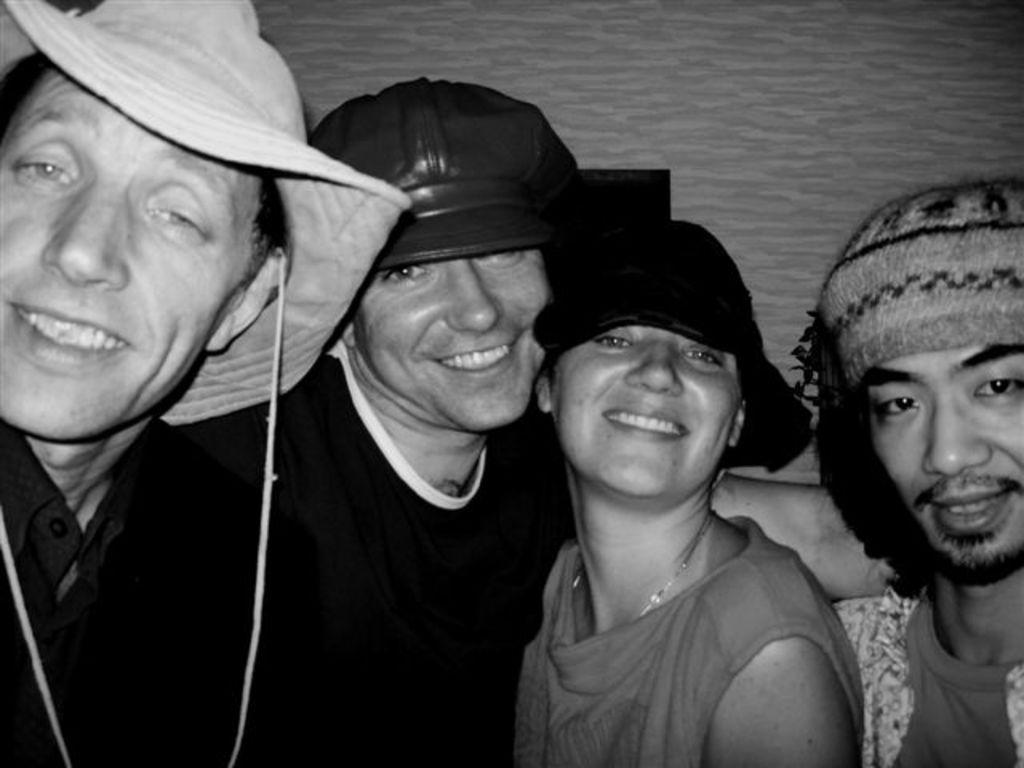Who or what can be seen in the image? There are people in the image. What are the people wearing on their heads? The people are wearing hats or caps. Can you describe any other objects or features in the image? There is an object and a wall in the image. How many pigs are visible in the image? There are no pigs present in the image. What type of coat is the person wearing in the image? There is no coat visible in the image, as the people are wearing hats or caps. 